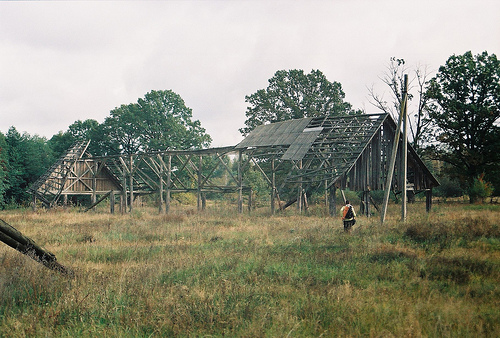<image>
Can you confirm if the roof is on the wood? Yes. Looking at the image, I can see the roof is positioned on top of the wood, with the wood providing support. 